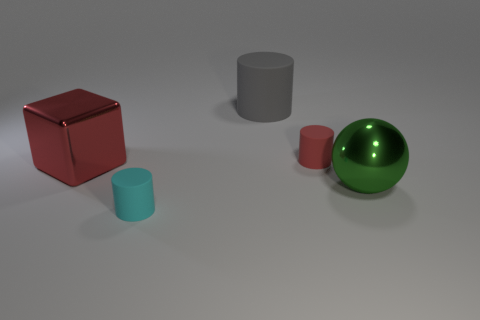Subtract all tiny matte cylinders. How many cylinders are left? 1 Add 3 green rubber cylinders. How many objects exist? 8 Subtract all spheres. How many objects are left? 4 Subtract all cyan cylinders. How many cylinders are left? 2 Subtract all cyan cylinders. Subtract all yellow cubes. How many cylinders are left? 2 Subtract all green cylinders. How many purple cubes are left? 0 Subtract all gray metal objects. Subtract all gray matte objects. How many objects are left? 4 Add 5 red rubber objects. How many red rubber objects are left? 6 Add 2 small red things. How many small red things exist? 3 Subtract 0 blue cylinders. How many objects are left? 5 